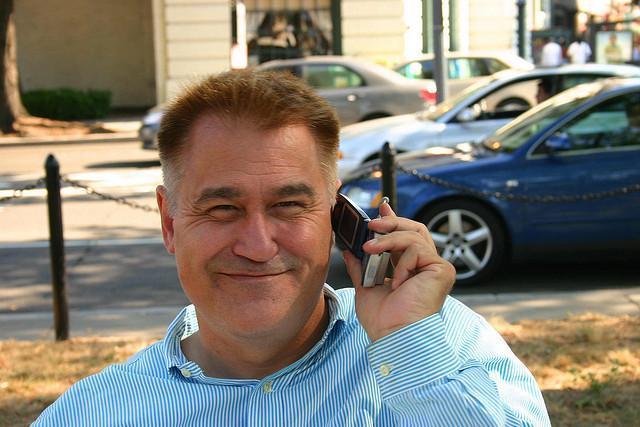How many cars are visible?
Give a very brief answer. 4. How many cell phones are there?
Give a very brief answer. 1. How many people are wearing orange glasses?
Give a very brief answer. 0. 